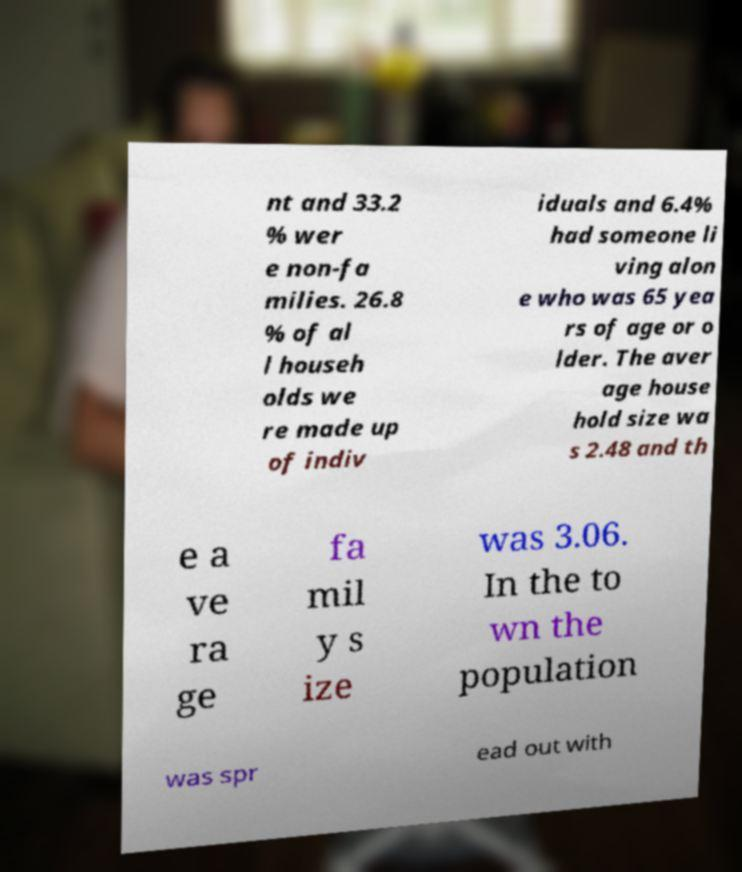Could you extract and type out the text from this image? nt and 33.2 % wer e non-fa milies. 26.8 % of al l househ olds we re made up of indiv iduals and 6.4% had someone li ving alon e who was 65 yea rs of age or o lder. The aver age house hold size wa s 2.48 and th e a ve ra ge fa mil y s ize was 3.06. In the to wn the population was spr ead out with 